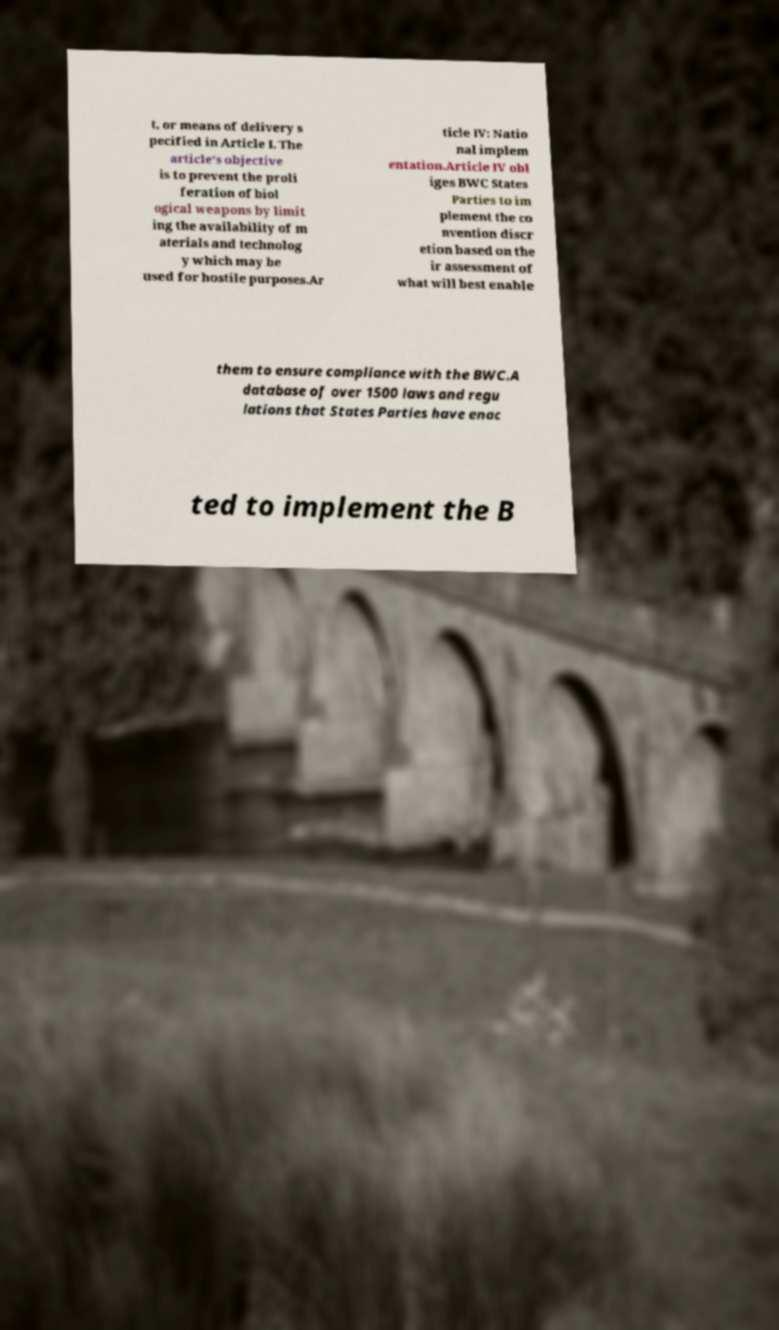For documentation purposes, I need the text within this image transcribed. Could you provide that? t, or means of delivery s pecified in Article I. The article's objective is to prevent the proli feration of biol ogical weapons by limit ing the availability of m aterials and technolog y which may be used for hostile purposes.Ar ticle IV: Natio nal implem entation.Article IV obl iges BWC States Parties to im plement the co nvention discr etion based on the ir assessment of what will best enable them to ensure compliance with the BWC.A database of over 1500 laws and regu lations that States Parties have enac ted to implement the B 